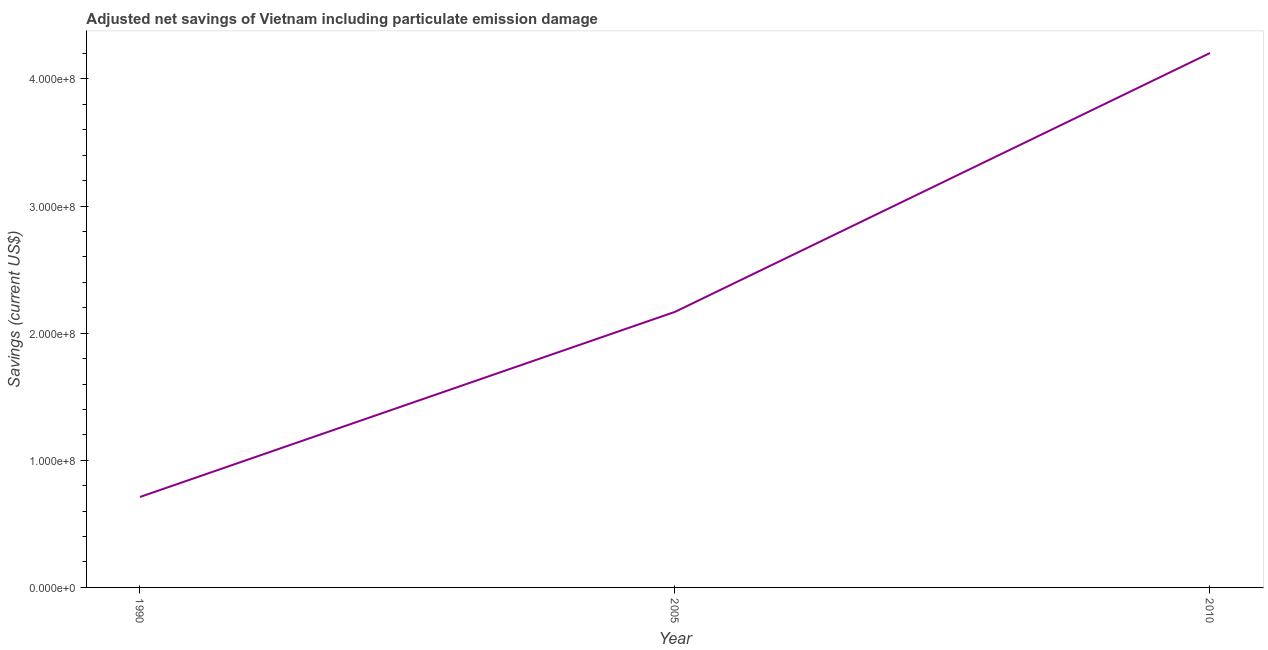What is the adjusted net savings in 1990?
Make the answer very short. 7.11e+07. Across all years, what is the maximum adjusted net savings?
Keep it short and to the point. 4.20e+08. Across all years, what is the minimum adjusted net savings?
Offer a terse response. 7.11e+07. In which year was the adjusted net savings maximum?
Provide a succinct answer. 2010. What is the sum of the adjusted net savings?
Offer a very short reply. 7.08e+08. What is the difference between the adjusted net savings in 1990 and 2010?
Your answer should be compact. -3.49e+08. What is the average adjusted net savings per year?
Offer a terse response. 2.36e+08. What is the median adjusted net savings?
Provide a short and direct response. 2.17e+08. In how many years, is the adjusted net savings greater than 300000000 US$?
Your answer should be compact. 1. Do a majority of the years between 2010 and 2005 (inclusive) have adjusted net savings greater than 80000000 US$?
Provide a succinct answer. No. What is the ratio of the adjusted net savings in 2005 to that in 2010?
Offer a very short reply. 0.52. What is the difference between the highest and the second highest adjusted net savings?
Your answer should be very brief. 2.04e+08. What is the difference between the highest and the lowest adjusted net savings?
Offer a terse response. 3.49e+08. In how many years, is the adjusted net savings greater than the average adjusted net savings taken over all years?
Your response must be concise. 1. How many years are there in the graph?
Provide a short and direct response. 3. Does the graph contain any zero values?
Ensure brevity in your answer.  No. Does the graph contain grids?
Your response must be concise. No. What is the title of the graph?
Your answer should be compact. Adjusted net savings of Vietnam including particulate emission damage. What is the label or title of the X-axis?
Your answer should be very brief. Year. What is the label or title of the Y-axis?
Provide a succinct answer. Savings (current US$). What is the Savings (current US$) of 1990?
Ensure brevity in your answer.  7.11e+07. What is the Savings (current US$) in 2005?
Make the answer very short. 2.17e+08. What is the Savings (current US$) in 2010?
Your response must be concise. 4.20e+08. What is the difference between the Savings (current US$) in 1990 and 2005?
Keep it short and to the point. -1.46e+08. What is the difference between the Savings (current US$) in 1990 and 2010?
Give a very brief answer. -3.49e+08. What is the difference between the Savings (current US$) in 2005 and 2010?
Provide a short and direct response. -2.04e+08. What is the ratio of the Savings (current US$) in 1990 to that in 2005?
Keep it short and to the point. 0.33. What is the ratio of the Savings (current US$) in 1990 to that in 2010?
Provide a short and direct response. 0.17. What is the ratio of the Savings (current US$) in 2005 to that in 2010?
Ensure brevity in your answer.  0.52. 